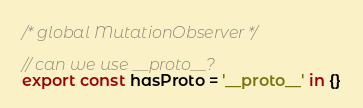<code> <loc_0><loc_0><loc_500><loc_500><_JavaScript_>/* global MutationObserver */

// can we use __proto__?
export const hasProto = '__proto__' in {}
</code> 